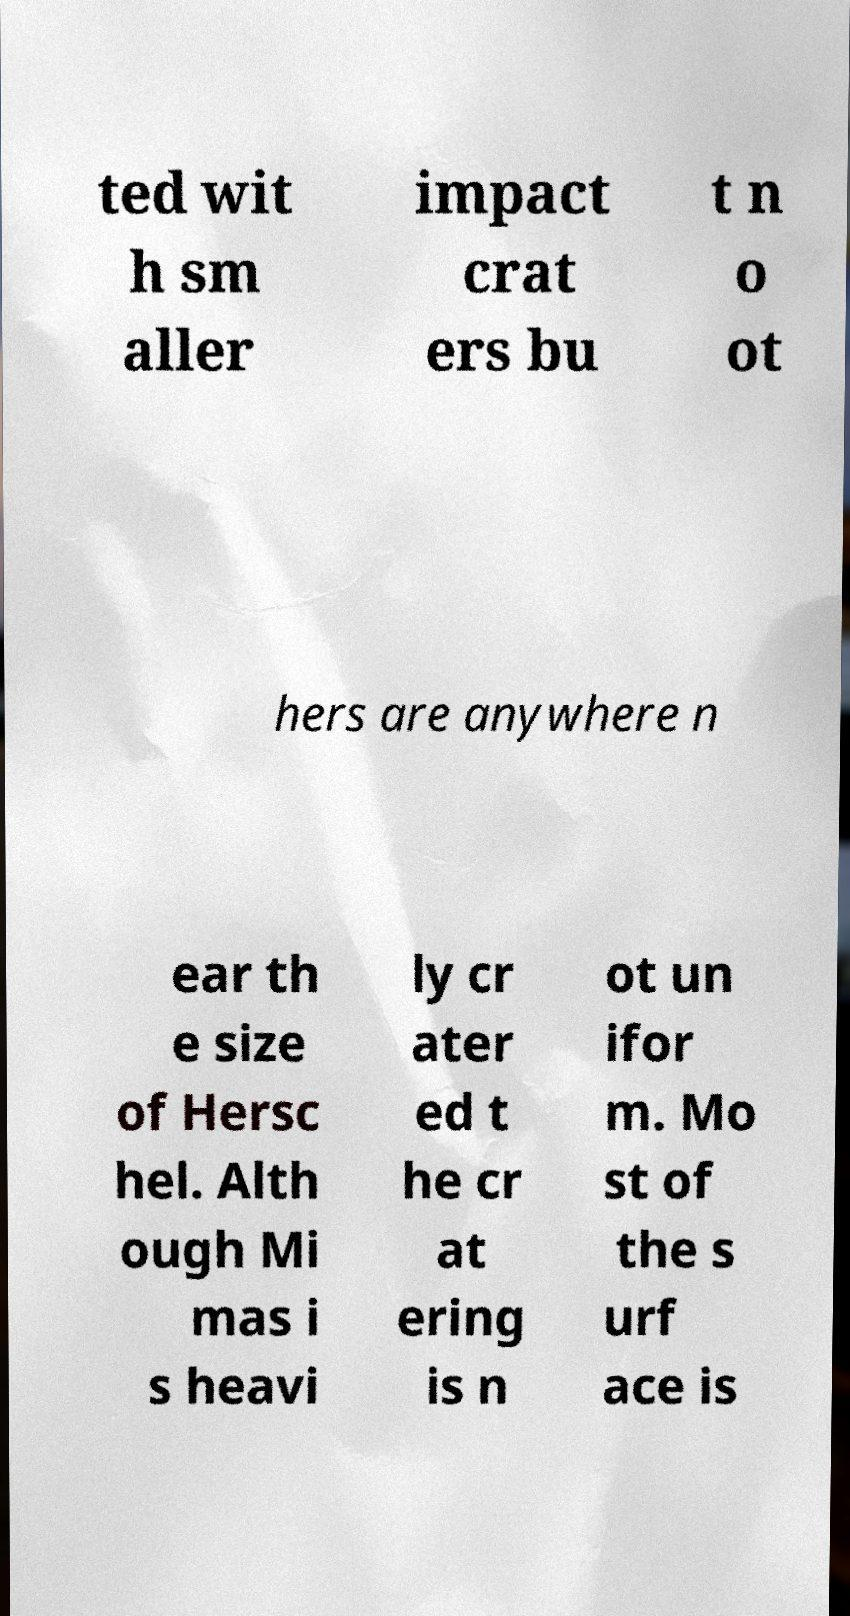Can you read and provide the text displayed in the image?This photo seems to have some interesting text. Can you extract and type it out for me? ted wit h sm aller impact crat ers bu t n o ot hers are anywhere n ear th e size of Hersc hel. Alth ough Mi mas i s heavi ly cr ater ed t he cr at ering is n ot un ifor m. Mo st of the s urf ace is 